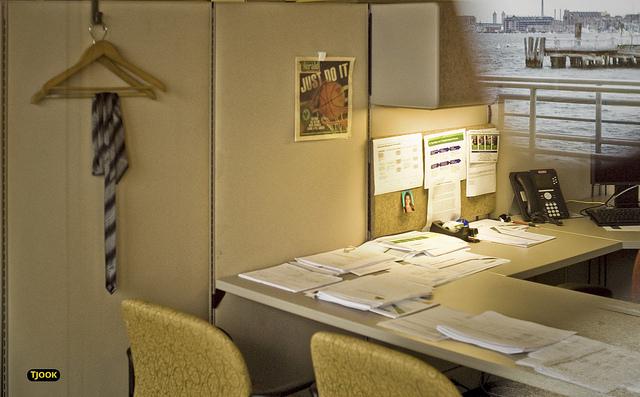What are the picture frames made of?
Keep it brief. Wood. Is there a phone on the desk?
Short answer required. Yes. What is on the desk?
Keep it brief. Papers. Are the papers organized?
Answer briefly. Yes. The yellow chairs are made of soft material?
Short answer required. No. What is on the hanger?
Concise answer only. Tie. 